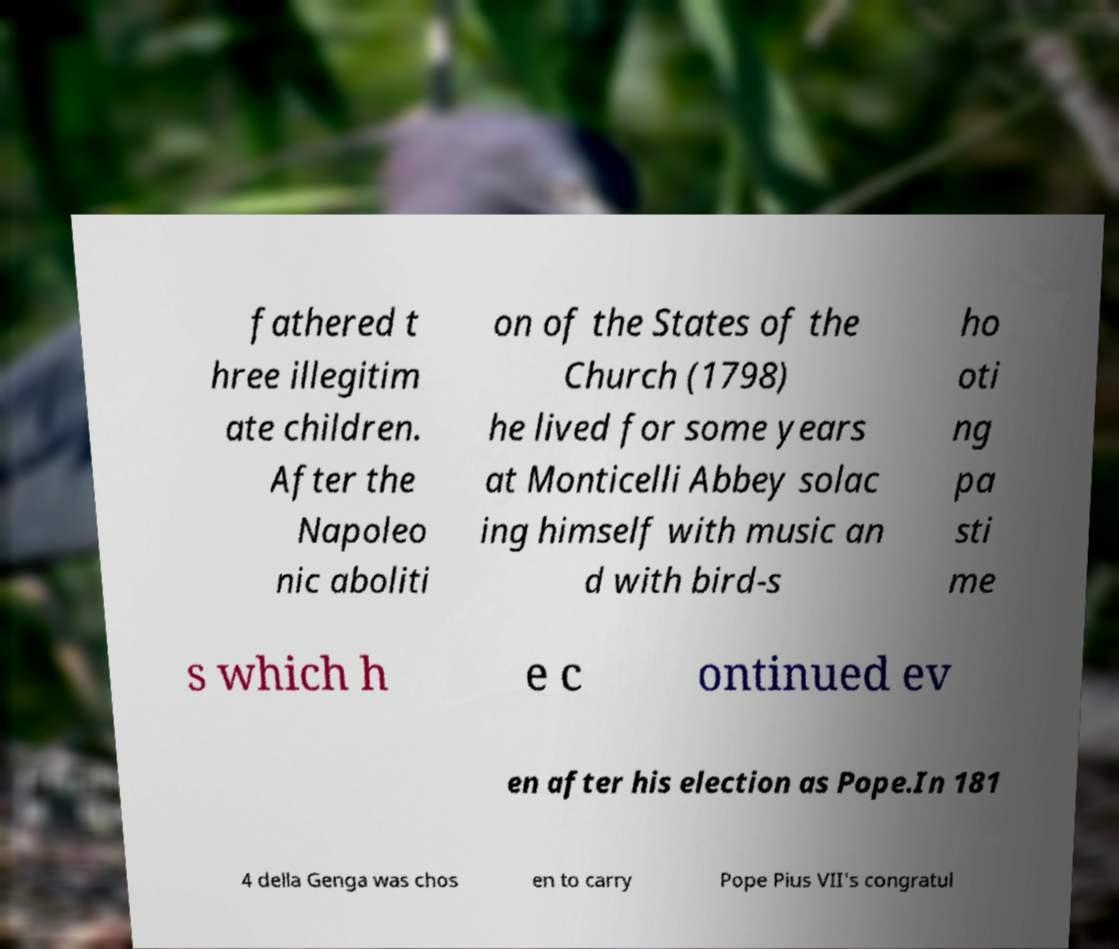Could you assist in decoding the text presented in this image and type it out clearly? fathered t hree illegitim ate children. After the Napoleo nic aboliti on of the States of the Church (1798) he lived for some years at Monticelli Abbey solac ing himself with music an d with bird-s ho oti ng pa sti me s which h e c ontinued ev en after his election as Pope.In 181 4 della Genga was chos en to carry Pope Pius VII's congratul 